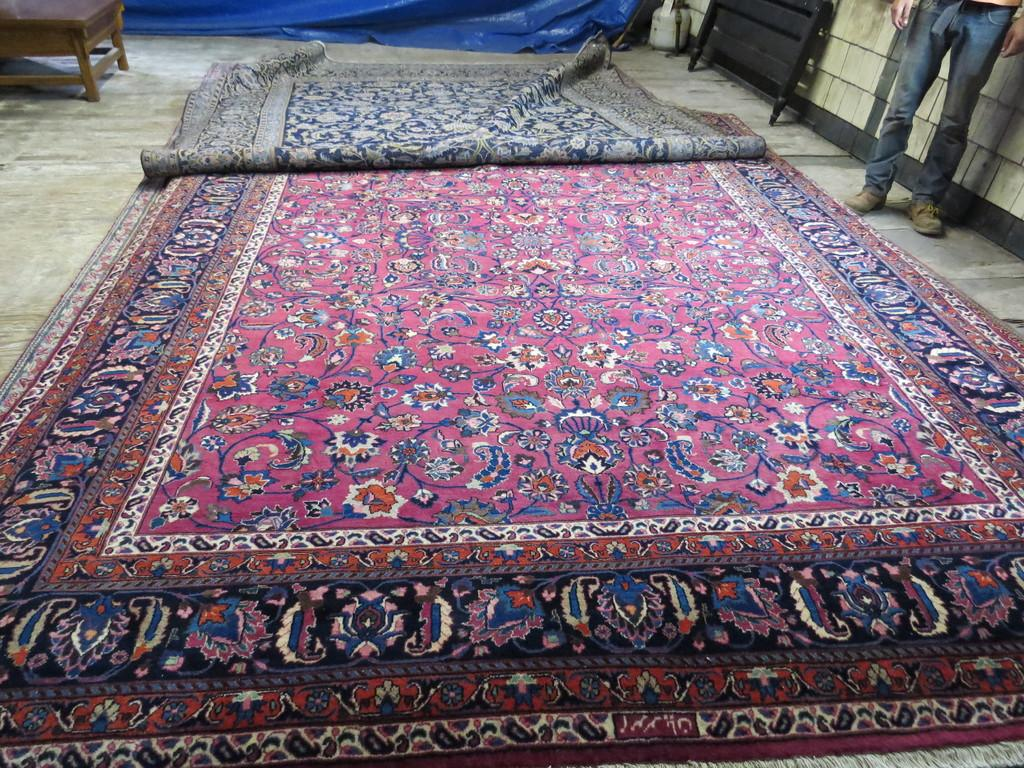What type of floor covering is visible in the image? There are carpets on the floor in the image. What is the person in the image doing? A person is standing in the image. What type of furniture is present in the image? There is a chair in the image. What type of paper is the mother holding in the image? There is no mother or paper present in the image. What type of clothing is the person wearing in the image? The provided facts do not mention any specific clothing, so we cannot determine the type of vest the person might be wearing. 